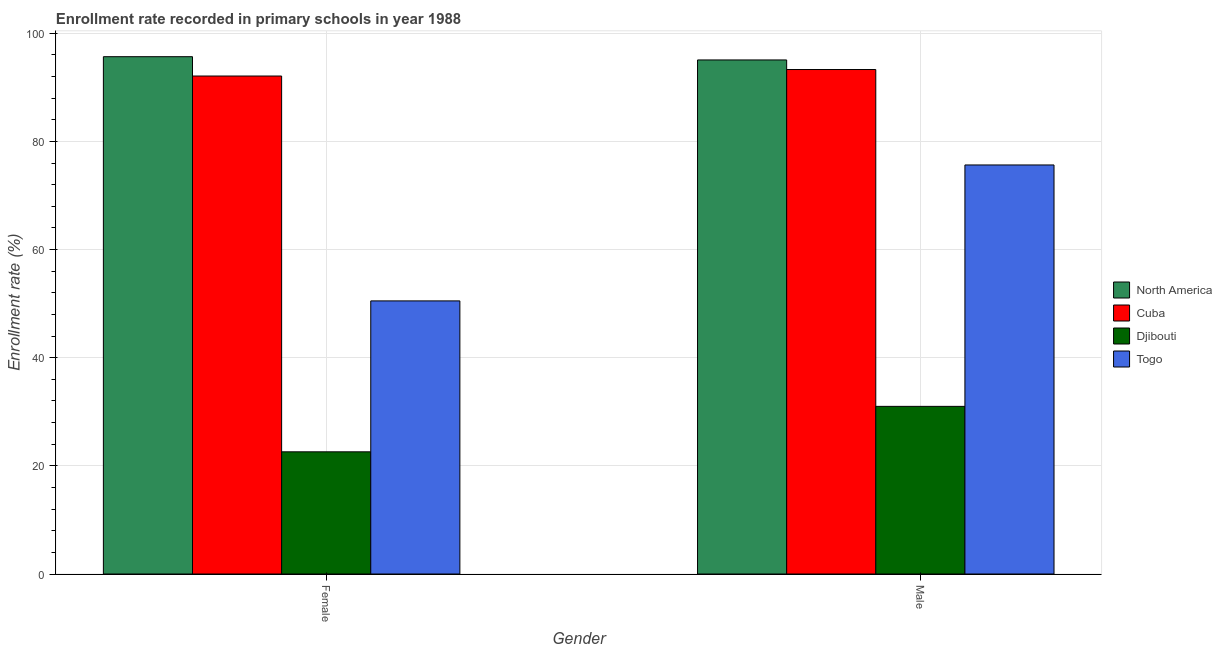How many different coloured bars are there?
Make the answer very short. 4. Are the number of bars per tick equal to the number of legend labels?
Your answer should be very brief. Yes. How many bars are there on the 1st tick from the left?
Your response must be concise. 4. What is the enrollment rate of male students in North America?
Your answer should be very brief. 95.08. Across all countries, what is the maximum enrollment rate of female students?
Keep it short and to the point. 95.69. Across all countries, what is the minimum enrollment rate of female students?
Make the answer very short. 22.6. In which country was the enrollment rate of male students maximum?
Offer a terse response. North America. In which country was the enrollment rate of male students minimum?
Make the answer very short. Djibouti. What is the total enrollment rate of male students in the graph?
Offer a terse response. 295.06. What is the difference between the enrollment rate of female students in Djibouti and that in Cuba?
Provide a succinct answer. -69.51. What is the difference between the enrollment rate of male students in Djibouti and the enrollment rate of female students in Togo?
Your response must be concise. -19.51. What is the average enrollment rate of female students per country?
Your response must be concise. 65.23. What is the difference between the enrollment rate of male students and enrollment rate of female students in Togo?
Your answer should be very brief. 25.14. What is the ratio of the enrollment rate of male students in Cuba to that in Djibouti?
Your response must be concise. 3.01. Is the enrollment rate of female students in Cuba less than that in North America?
Give a very brief answer. Yes. In how many countries, is the enrollment rate of female students greater than the average enrollment rate of female students taken over all countries?
Offer a very short reply. 2. What does the 3rd bar from the left in Male represents?
Give a very brief answer. Djibouti. Are all the bars in the graph horizontal?
Provide a short and direct response. No. What is the difference between two consecutive major ticks on the Y-axis?
Your answer should be very brief. 20. Are the values on the major ticks of Y-axis written in scientific E-notation?
Your answer should be compact. No. Where does the legend appear in the graph?
Your answer should be very brief. Center right. How are the legend labels stacked?
Offer a very short reply. Vertical. What is the title of the graph?
Your answer should be compact. Enrollment rate recorded in primary schools in year 1988. Does "Jamaica" appear as one of the legend labels in the graph?
Keep it short and to the point. No. What is the label or title of the X-axis?
Give a very brief answer. Gender. What is the label or title of the Y-axis?
Your answer should be very brief. Enrollment rate (%). What is the Enrollment rate (%) in North America in Female?
Your answer should be compact. 95.69. What is the Enrollment rate (%) of Cuba in Female?
Your response must be concise. 92.11. What is the Enrollment rate (%) of Djibouti in Female?
Offer a terse response. 22.6. What is the Enrollment rate (%) in Togo in Female?
Ensure brevity in your answer.  50.51. What is the Enrollment rate (%) of North America in Male?
Provide a short and direct response. 95.08. What is the Enrollment rate (%) in Cuba in Male?
Your answer should be very brief. 93.31. What is the Enrollment rate (%) in Djibouti in Male?
Provide a succinct answer. 31.01. What is the Enrollment rate (%) in Togo in Male?
Give a very brief answer. 75.66. Across all Gender, what is the maximum Enrollment rate (%) in North America?
Give a very brief answer. 95.69. Across all Gender, what is the maximum Enrollment rate (%) of Cuba?
Provide a short and direct response. 93.31. Across all Gender, what is the maximum Enrollment rate (%) of Djibouti?
Offer a very short reply. 31.01. Across all Gender, what is the maximum Enrollment rate (%) in Togo?
Provide a succinct answer. 75.66. Across all Gender, what is the minimum Enrollment rate (%) in North America?
Ensure brevity in your answer.  95.08. Across all Gender, what is the minimum Enrollment rate (%) of Cuba?
Give a very brief answer. 92.11. Across all Gender, what is the minimum Enrollment rate (%) of Djibouti?
Give a very brief answer. 22.6. Across all Gender, what is the minimum Enrollment rate (%) in Togo?
Ensure brevity in your answer.  50.51. What is the total Enrollment rate (%) in North America in the graph?
Provide a short and direct response. 190.77. What is the total Enrollment rate (%) in Cuba in the graph?
Offer a terse response. 185.42. What is the total Enrollment rate (%) in Djibouti in the graph?
Provide a succinct answer. 53.61. What is the total Enrollment rate (%) in Togo in the graph?
Your answer should be compact. 126.17. What is the difference between the Enrollment rate (%) in North America in Female and that in Male?
Your answer should be compact. 0.6. What is the difference between the Enrollment rate (%) of Cuba in Female and that in Male?
Keep it short and to the point. -1.2. What is the difference between the Enrollment rate (%) in Djibouti in Female and that in Male?
Provide a succinct answer. -8.41. What is the difference between the Enrollment rate (%) of Togo in Female and that in Male?
Offer a very short reply. -25.14. What is the difference between the Enrollment rate (%) of North America in Female and the Enrollment rate (%) of Cuba in Male?
Keep it short and to the point. 2.37. What is the difference between the Enrollment rate (%) in North America in Female and the Enrollment rate (%) in Djibouti in Male?
Give a very brief answer. 64.68. What is the difference between the Enrollment rate (%) in North America in Female and the Enrollment rate (%) in Togo in Male?
Give a very brief answer. 20.03. What is the difference between the Enrollment rate (%) of Cuba in Female and the Enrollment rate (%) of Djibouti in Male?
Your response must be concise. 61.1. What is the difference between the Enrollment rate (%) of Cuba in Female and the Enrollment rate (%) of Togo in Male?
Give a very brief answer. 16.45. What is the difference between the Enrollment rate (%) of Djibouti in Female and the Enrollment rate (%) of Togo in Male?
Provide a short and direct response. -53.06. What is the average Enrollment rate (%) of North America per Gender?
Give a very brief answer. 95.38. What is the average Enrollment rate (%) in Cuba per Gender?
Offer a terse response. 92.71. What is the average Enrollment rate (%) of Djibouti per Gender?
Give a very brief answer. 26.8. What is the average Enrollment rate (%) in Togo per Gender?
Offer a terse response. 63.09. What is the difference between the Enrollment rate (%) in North America and Enrollment rate (%) in Cuba in Female?
Provide a short and direct response. 3.58. What is the difference between the Enrollment rate (%) in North America and Enrollment rate (%) in Djibouti in Female?
Your response must be concise. 73.09. What is the difference between the Enrollment rate (%) in North America and Enrollment rate (%) in Togo in Female?
Your answer should be compact. 45.17. What is the difference between the Enrollment rate (%) in Cuba and Enrollment rate (%) in Djibouti in Female?
Keep it short and to the point. 69.51. What is the difference between the Enrollment rate (%) of Cuba and Enrollment rate (%) of Togo in Female?
Ensure brevity in your answer.  41.59. What is the difference between the Enrollment rate (%) in Djibouti and Enrollment rate (%) in Togo in Female?
Give a very brief answer. -27.91. What is the difference between the Enrollment rate (%) of North America and Enrollment rate (%) of Cuba in Male?
Ensure brevity in your answer.  1.77. What is the difference between the Enrollment rate (%) of North America and Enrollment rate (%) of Djibouti in Male?
Offer a very short reply. 64.08. What is the difference between the Enrollment rate (%) of North America and Enrollment rate (%) of Togo in Male?
Offer a terse response. 19.43. What is the difference between the Enrollment rate (%) of Cuba and Enrollment rate (%) of Djibouti in Male?
Your response must be concise. 62.31. What is the difference between the Enrollment rate (%) in Cuba and Enrollment rate (%) in Togo in Male?
Your answer should be very brief. 17.65. What is the difference between the Enrollment rate (%) in Djibouti and Enrollment rate (%) in Togo in Male?
Provide a succinct answer. -44.65. What is the ratio of the Enrollment rate (%) of North America in Female to that in Male?
Provide a succinct answer. 1.01. What is the ratio of the Enrollment rate (%) in Cuba in Female to that in Male?
Keep it short and to the point. 0.99. What is the ratio of the Enrollment rate (%) in Djibouti in Female to that in Male?
Give a very brief answer. 0.73. What is the ratio of the Enrollment rate (%) of Togo in Female to that in Male?
Your answer should be compact. 0.67. What is the difference between the highest and the second highest Enrollment rate (%) in North America?
Offer a very short reply. 0.6. What is the difference between the highest and the second highest Enrollment rate (%) in Cuba?
Your answer should be compact. 1.2. What is the difference between the highest and the second highest Enrollment rate (%) of Djibouti?
Your answer should be very brief. 8.41. What is the difference between the highest and the second highest Enrollment rate (%) of Togo?
Make the answer very short. 25.14. What is the difference between the highest and the lowest Enrollment rate (%) of North America?
Ensure brevity in your answer.  0.6. What is the difference between the highest and the lowest Enrollment rate (%) of Cuba?
Your answer should be compact. 1.2. What is the difference between the highest and the lowest Enrollment rate (%) of Djibouti?
Make the answer very short. 8.41. What is the difference between the highest and the lowest Enrollment rate (%) of Togo?
Provide a succinct answer. 25.14. 